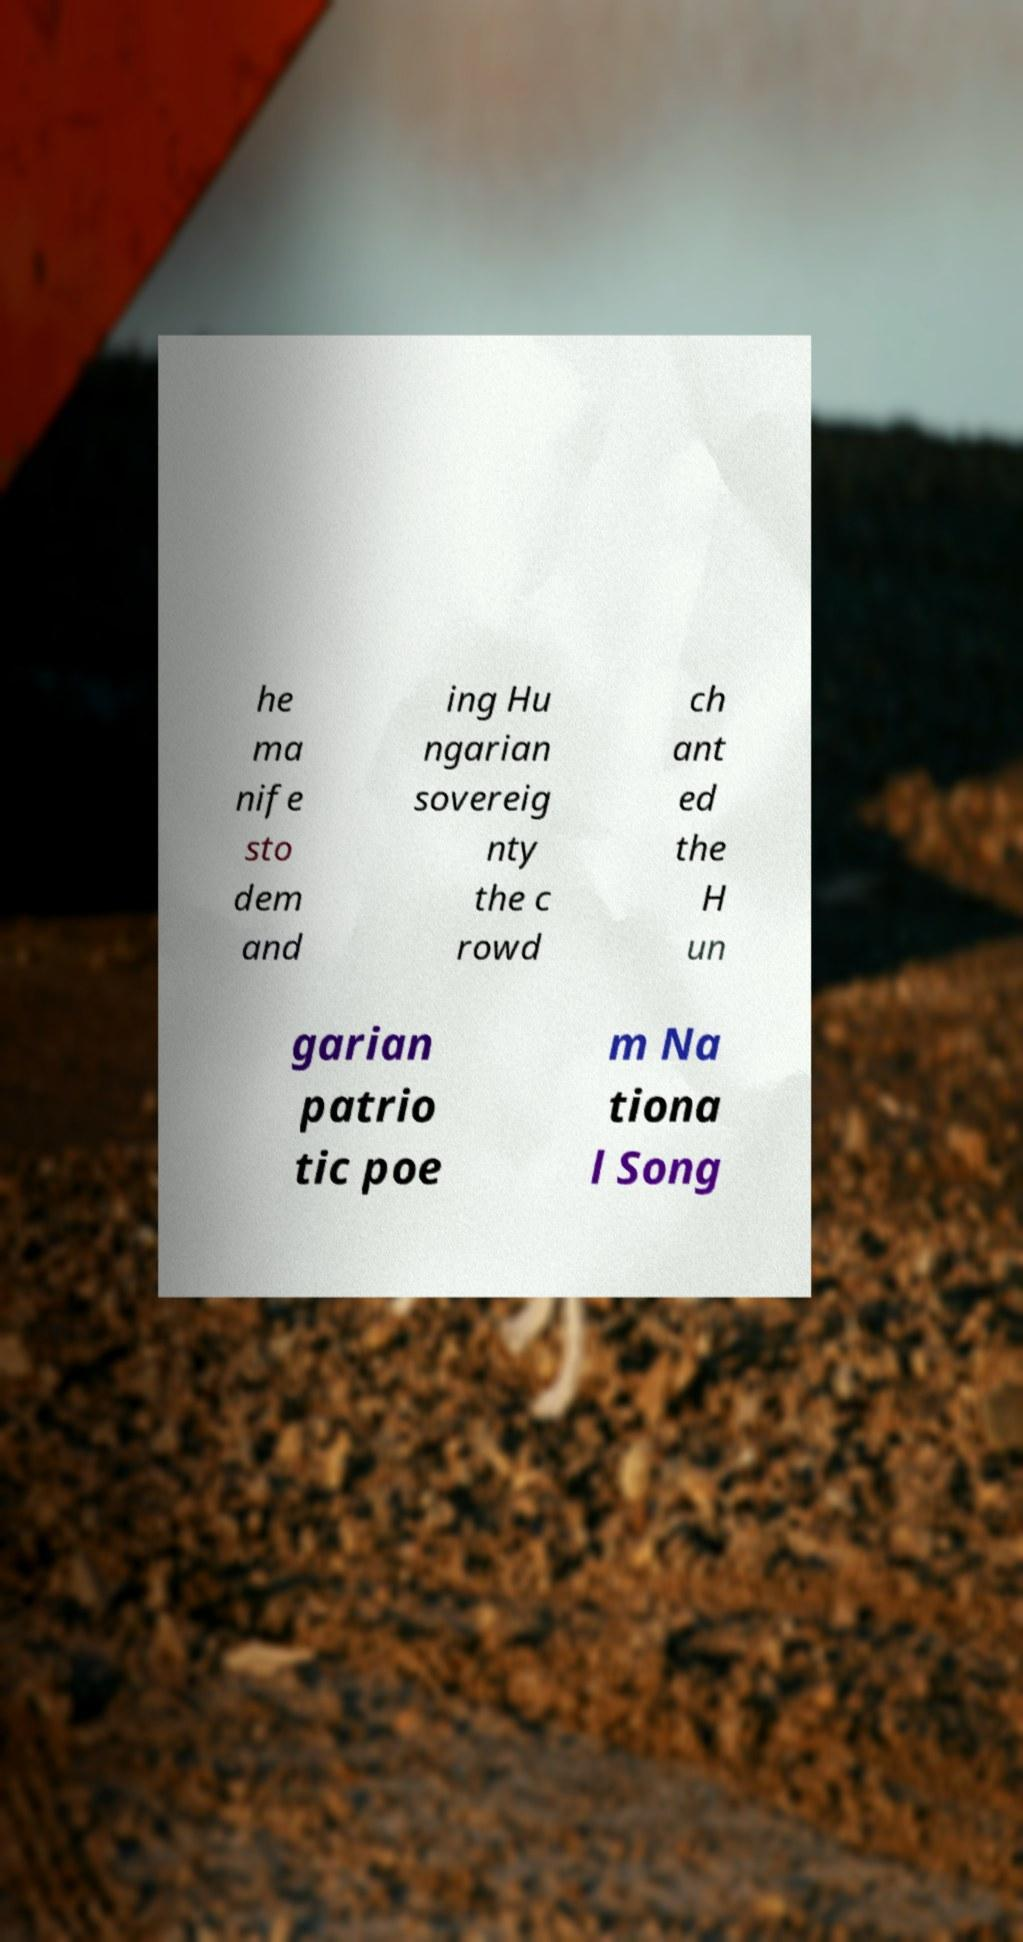For documentation purposes, I need the text within this image transcribed. Could you provide that? he ma nife sto dem and ing Hu ngarian sovereig nty the c rowd ch ant ed the H un garian patrio tic poe m Na tiona l Song 